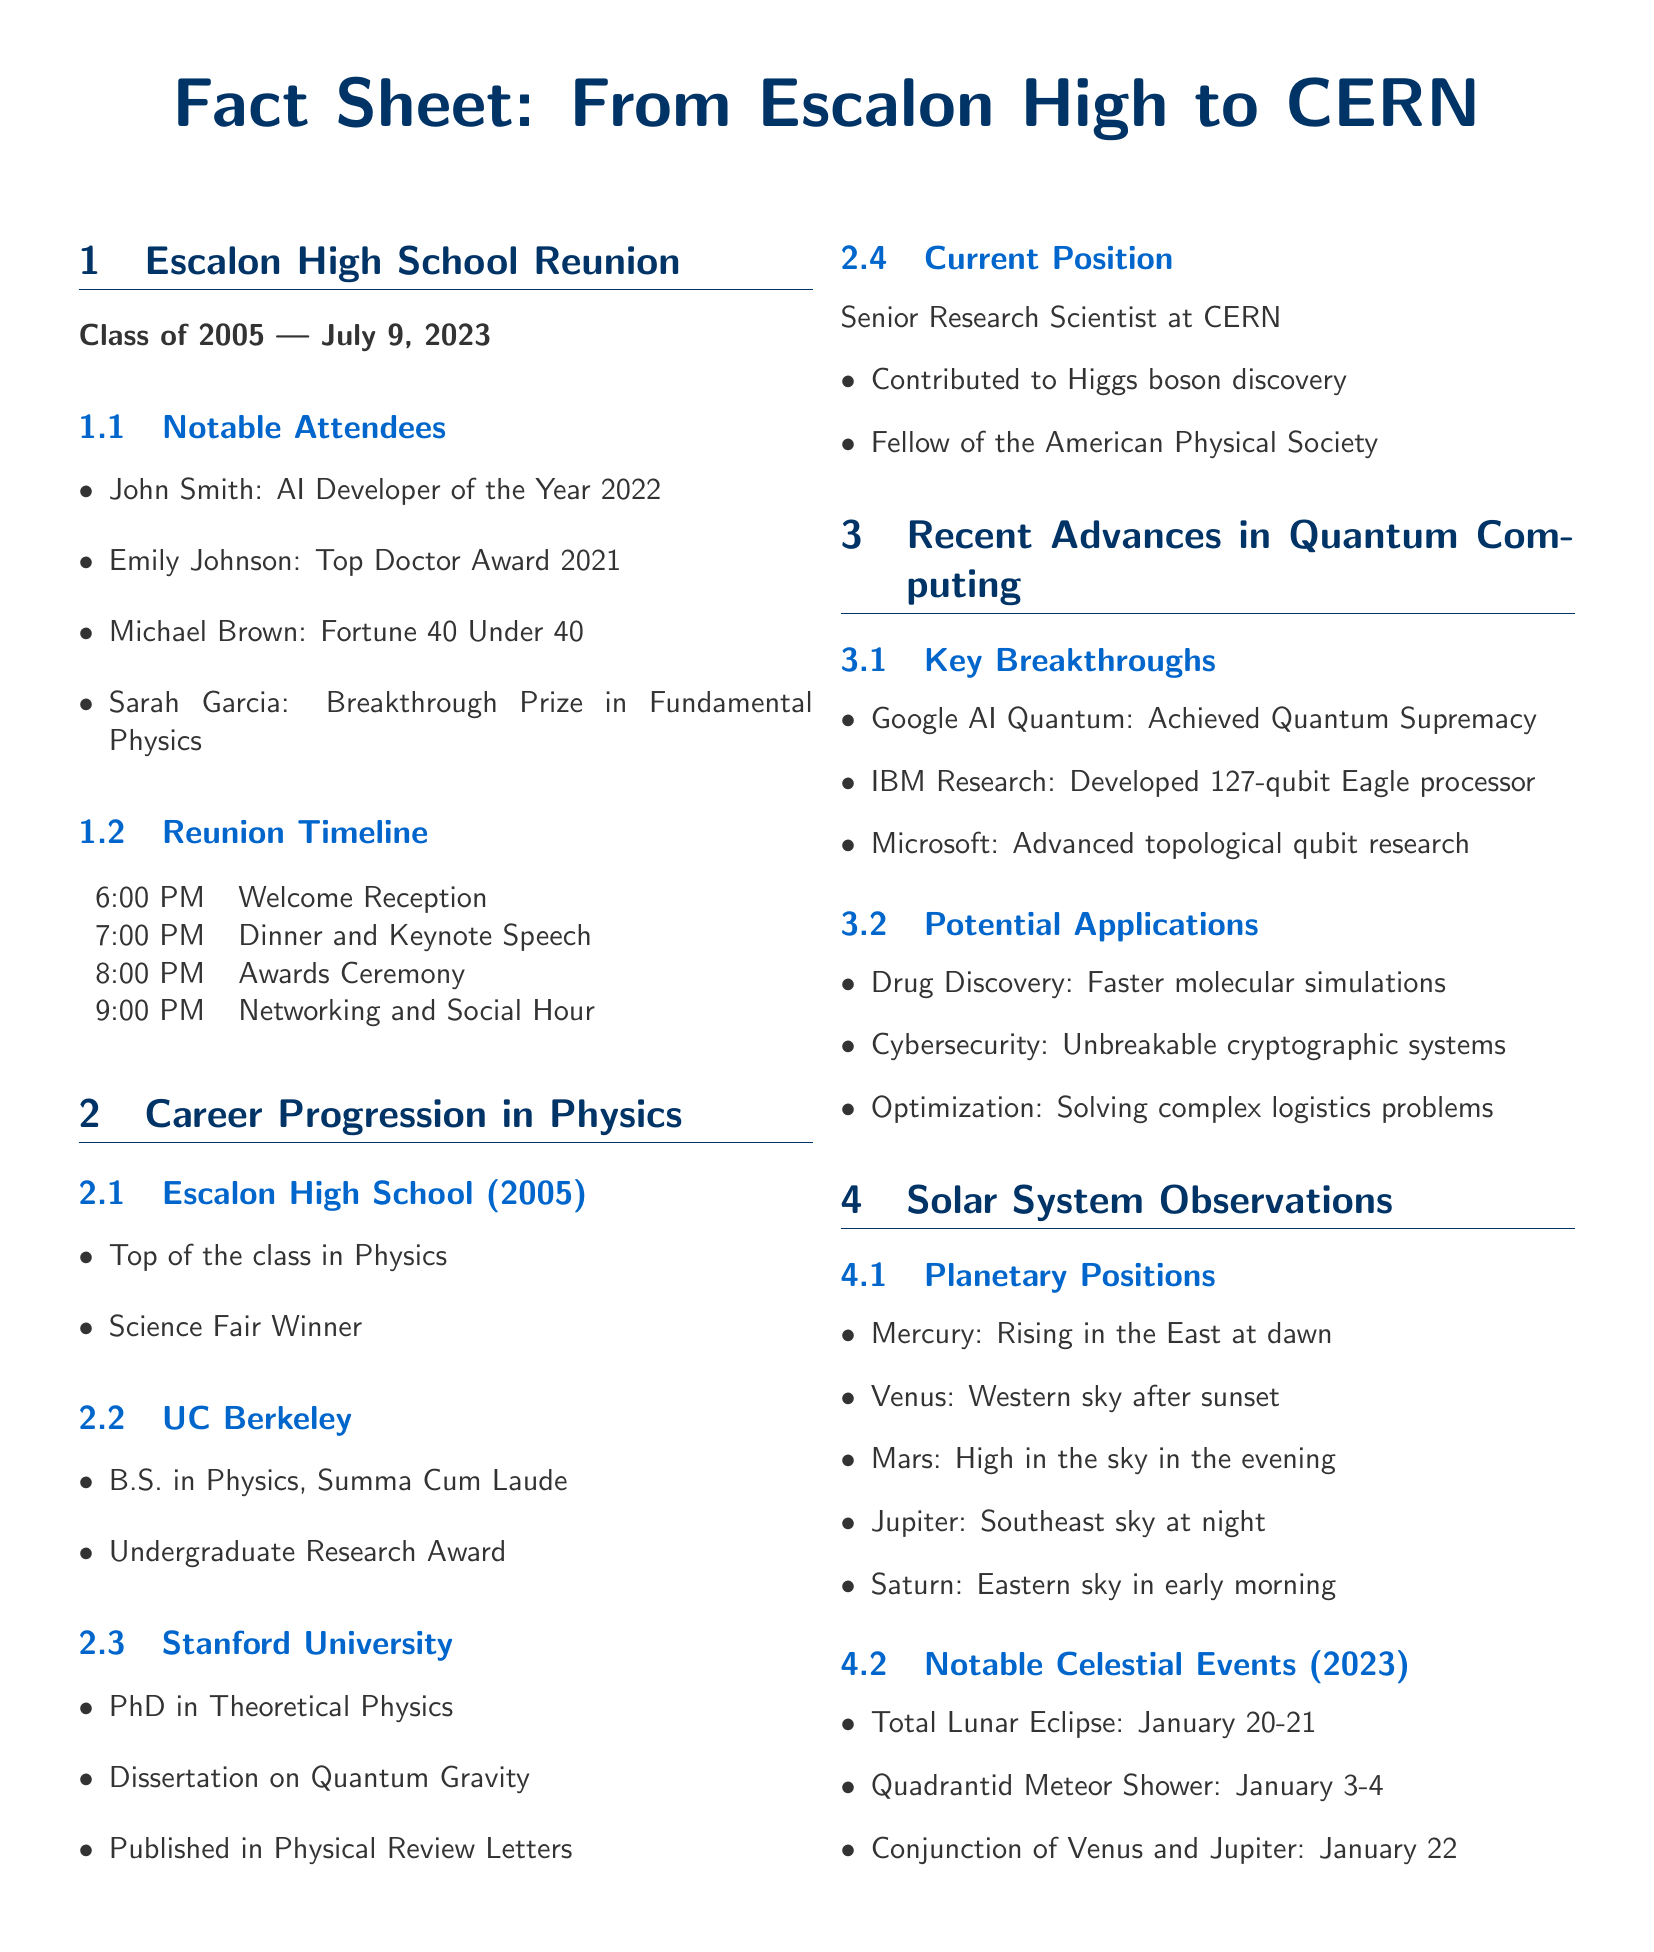What year did the Escalon High School reunion take place? The document lists the reunion date for the Class of 2005 as July 9, 2023.
Answer: July 9, 2023 Who received the Breakthrough Prize in Fundamental Physics? The notable attendees include Sarah Garcia, who received this award according to the document.
Answer: Sarah Garcia What was the highest education degree obtained? The document states that the highest degree obtained was a PhD in Theoretical Physics from Stanford University.
Answer: PhD in Theoretical Physics Which institution achieved Quantum Supremacy? The document identifies Google AI Quantum as the entity that achieved this significant milestone.
Answer: Google AI Quantum What was one notable celestial event in January 2023? The document mentions a Total Lunar Eclipse occurring on January 20-21, 2023.
Answer: Total Lunar Eclipse How many qubits does IBM's Eagle processor have? The document specifies that the IBM Research developed a 127-qubit Eagle processor.
Answer: 127-qubit What key role did the Senior Research Scientist at CERN contribute to? According to the document, the Senior Research Scientist contributed to the discovery of the Higgs boson.
Answer: Higgs boson discovery What was the main focus of the dissertation completed at Stanford? The document lists the dissertation's focus as Quantum Gravity while outlining the academic achievements.
Answer: Quantum Gravity 